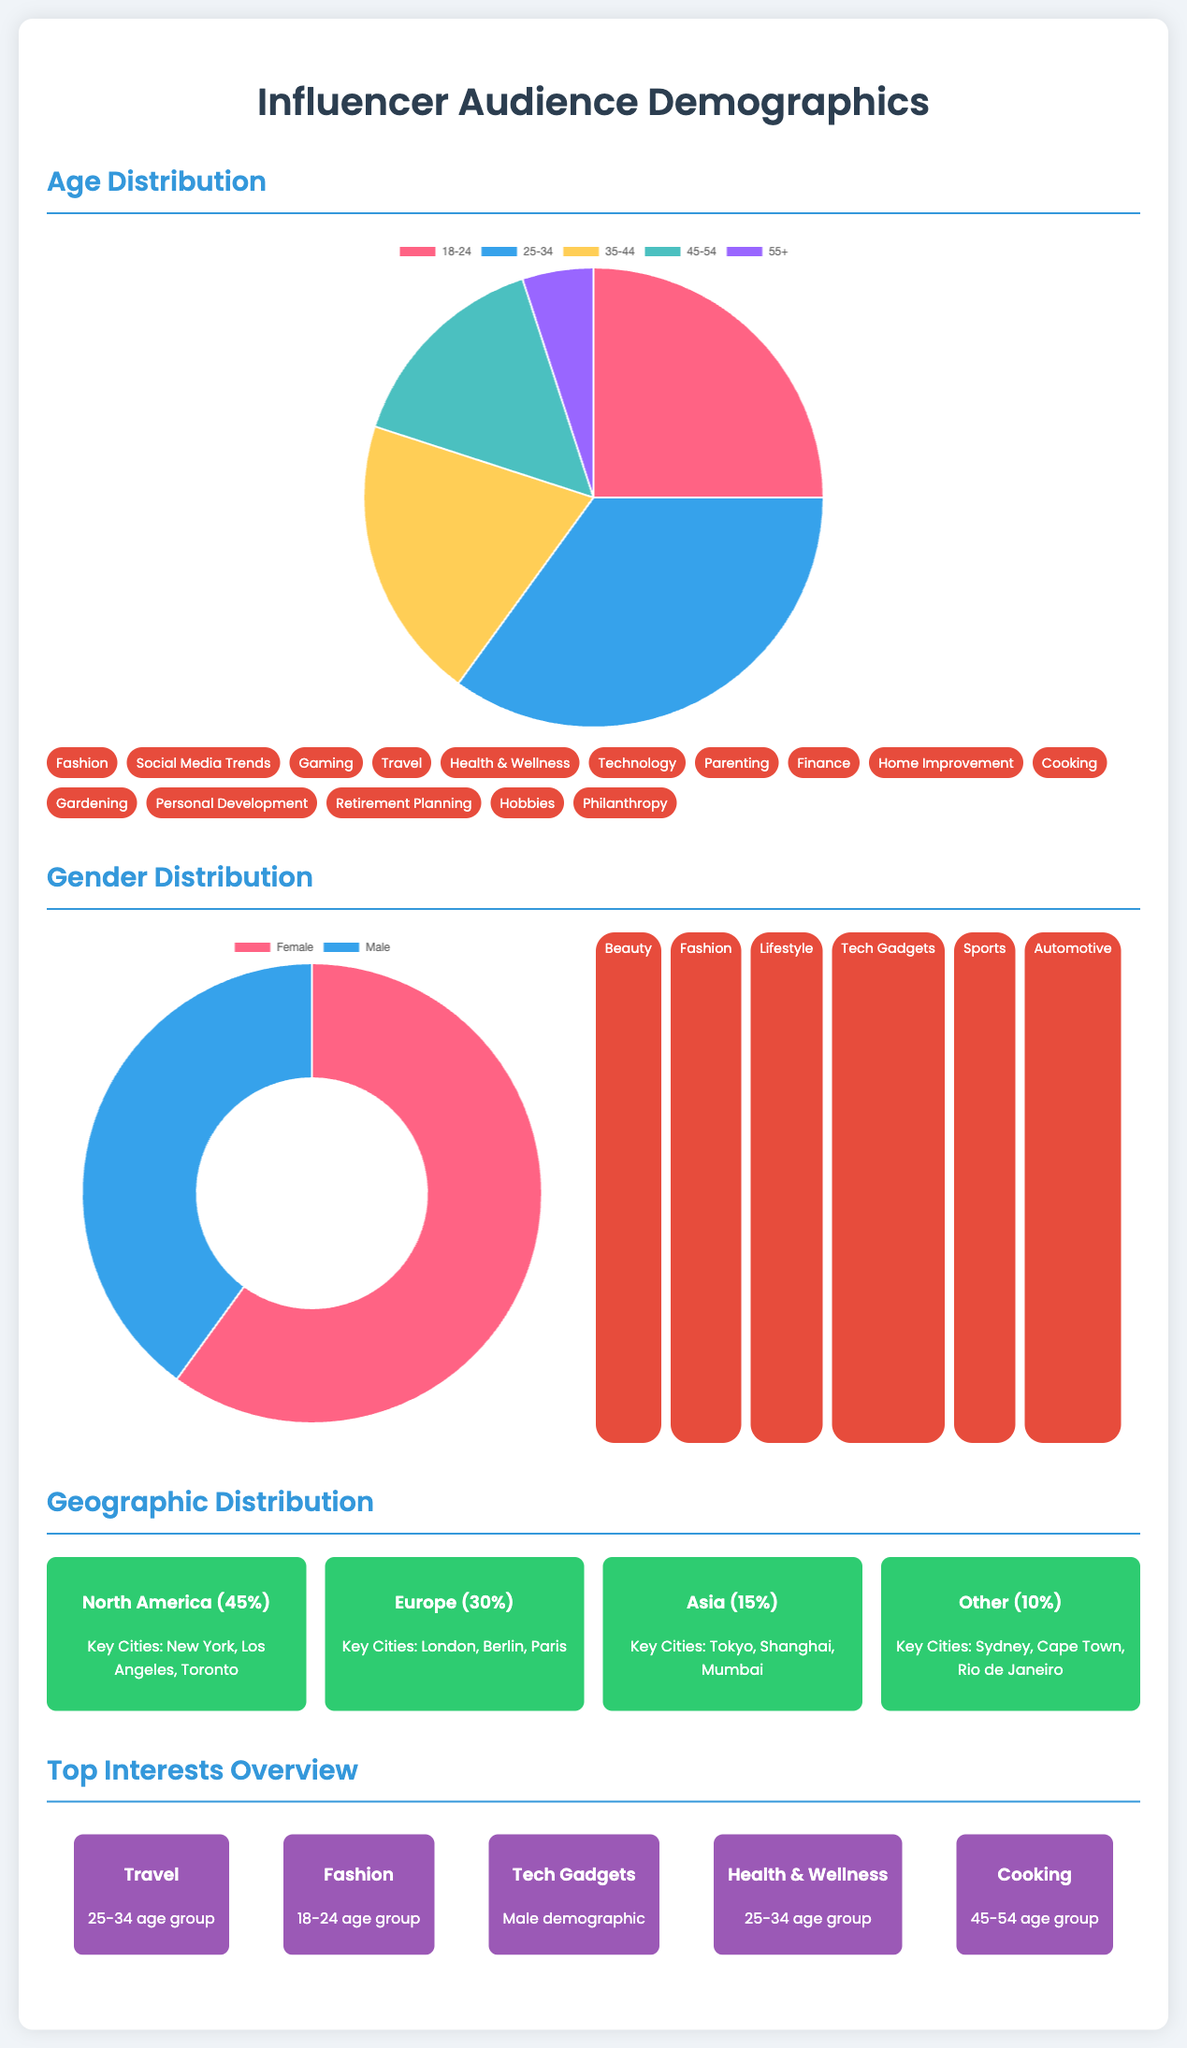What age group has the highest percentage? The age group with the highest percentage in the age distribution chart is 25-34, which accounts for 35%.
Answer: 25-34 What percentage of the audience is male? The gender distribution shows that the male audience makes up 40% of the total audience.
Answer: 40% Which region has the largest audience percentage? North America has the largest audience percentage at 45%.
Answer: 45% What is the top interest for the 25-34 age group? The top interest for the 25-34 age group is Travel.
Answer: Travel How many interest tags are listed under Age Distribution? There are a total of 14 interest tags provided in the Age Distribution section.
Answer: 14 What is the total percentage of the audience from Europe and Asia combined? The combined percentage of the audience from Europe (30%) and Asia (15%) totals 45%.
Answer: 45% What demographic is most interested in Tech Gadgets? The male demographic is most interested in Tech Gadgets.
Answer: Male How many key cities are mentioned for North America? Three key cities are mentioned for North America: New York, Los Angeles, and Toronto.
Answer: Three What is the title of the document? The title of the document is "Influencer Audience Demographics."
Answer: Influencer Audience Demographics 